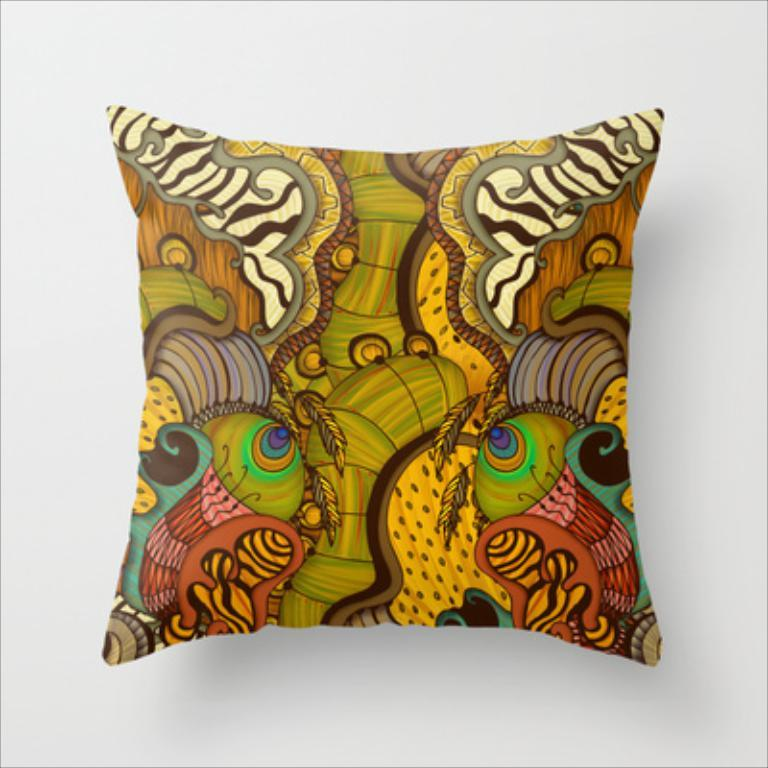What type of object is featured in the image? There is a colorful pillow in the image. Can you describe the pillow's location in the image? The pillow is on a surface. What type of prison can be seen in the background of the image? There is no prison present in the image; it only features a colorful pillow on a surface. 